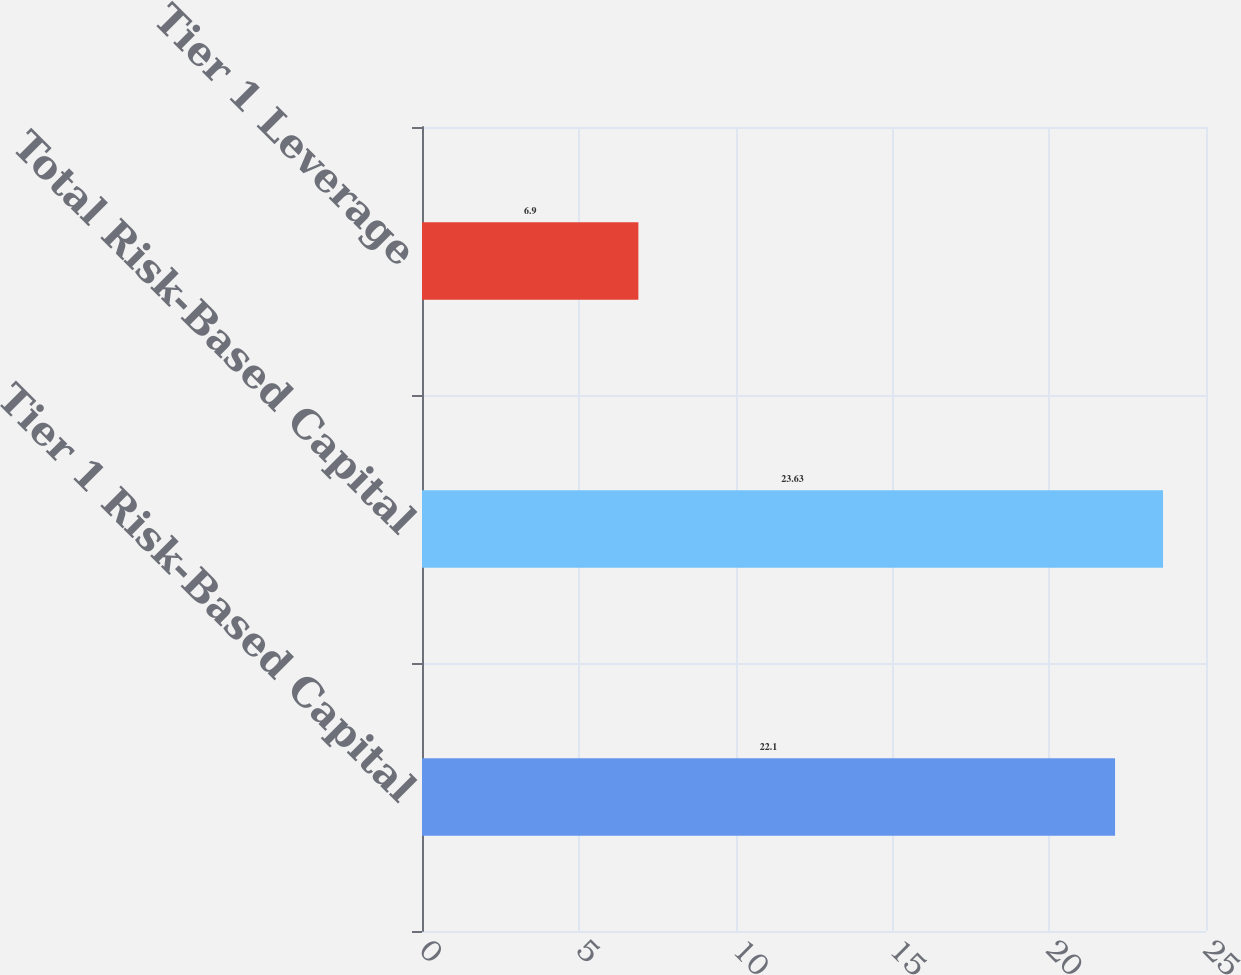Convert chart to OTSL. <chart><loc_0><loc_0><loc_500><loc_500><bar_chart><fcel>Tier 1 Risk-Based Capital<fcel>Total Risk-Based Capital<fcel>Tier 1 Leverage<nl><fcel>22.1<fcel>23.63<fcel>6.9<nl></chart> 